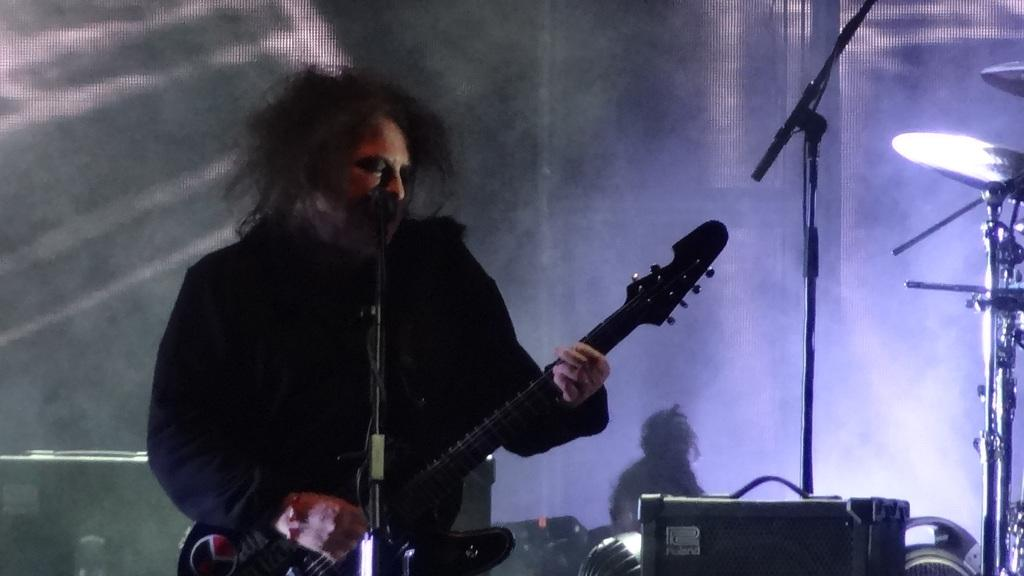What activity are the people in the image engaged in? The people in the image are sitting around a table. What might be the purpose of the people sitting around the table? The people might be having a meal together. Can you describe the setting where the people are sitting? The setting is around a table. What type of pen is being used by the people sitting around the table? There is no pen present in the image; the people are having a meal together. Are the people wearing mittens while sitting around the table? There is no mention of mittens in the image, and it is unlikely that people would be wearing mittens while having a meal. 